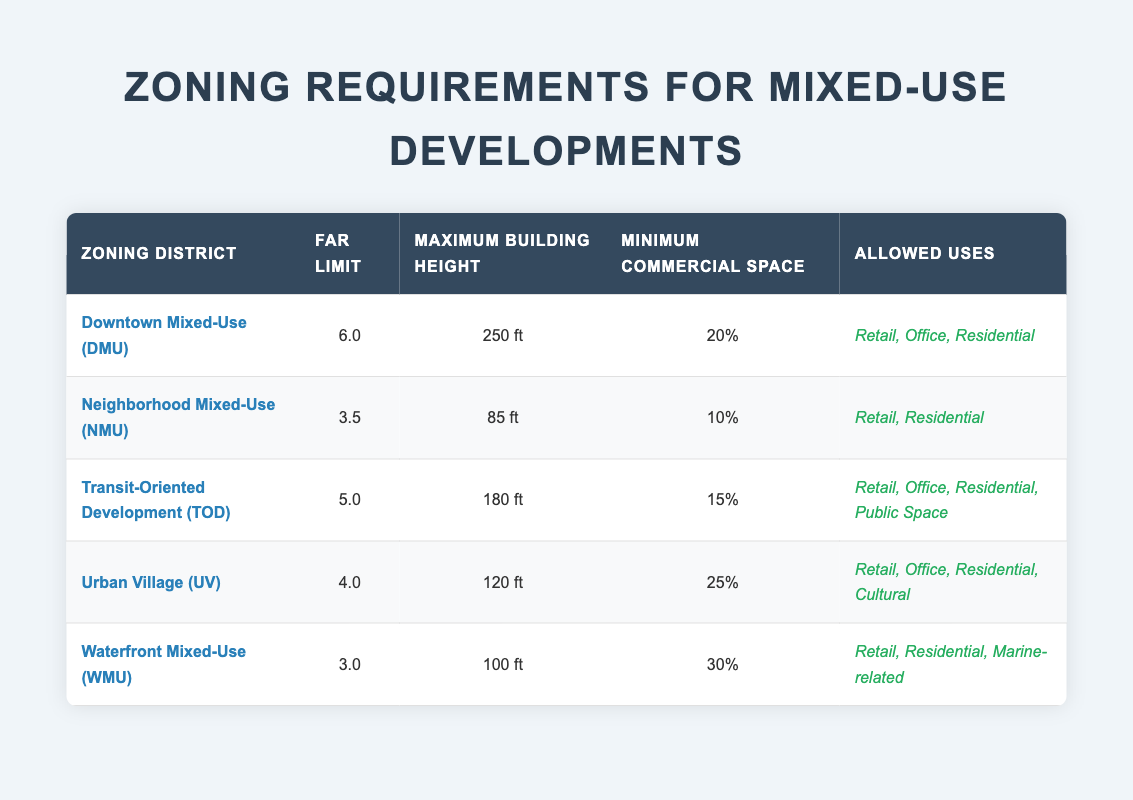What's the FAR limit for Downtown Mixed-Use? The FAR limit for Downtown Mixed-Use (DMU) is found directly in the table under the "FAR Limit" column for that zoning district. The value listed is 6.0.
Answer: 6.0 What is the maximum building height allowed in the Neighborhood Mixed-Use district? The maximum building height for the Neighborhood Mixed-Use (NMU) district is located in the "Maximum Building Height" column corresponding to NMU. The value given is 85 ft.
Answer: 85 ft Is Residential use allowed in Urban Village zoning? To find out if Residential use is allowed in the Urban Village (UV) zoning district, we can check the "Allowed Uses" column for UV. The entry includes Residential, indicating that it is permitted.
Answer: Yes What is the difference in FAR limits between Downtown Mixed-Use and Waterfront Mixed-Use? First, locate the FAR limits of each zoning district: Downtown Mixed-Use (DMU) is 6.0 and Waterfront Mixed-Use (WMU) is 3.0. The difference is 6.0 - 3.0, resulting in 3.0.
Answer: 3.0 How many zoning districts allow Office use? The "Allowed Uses" column needs to be examined for each district. The Downtown Mixed-Use, Transit-Oriented Development, and Urban Village all include Office in their allowed uses. Thus, there are three zoning districts that allow Office use.
Answer: 3 